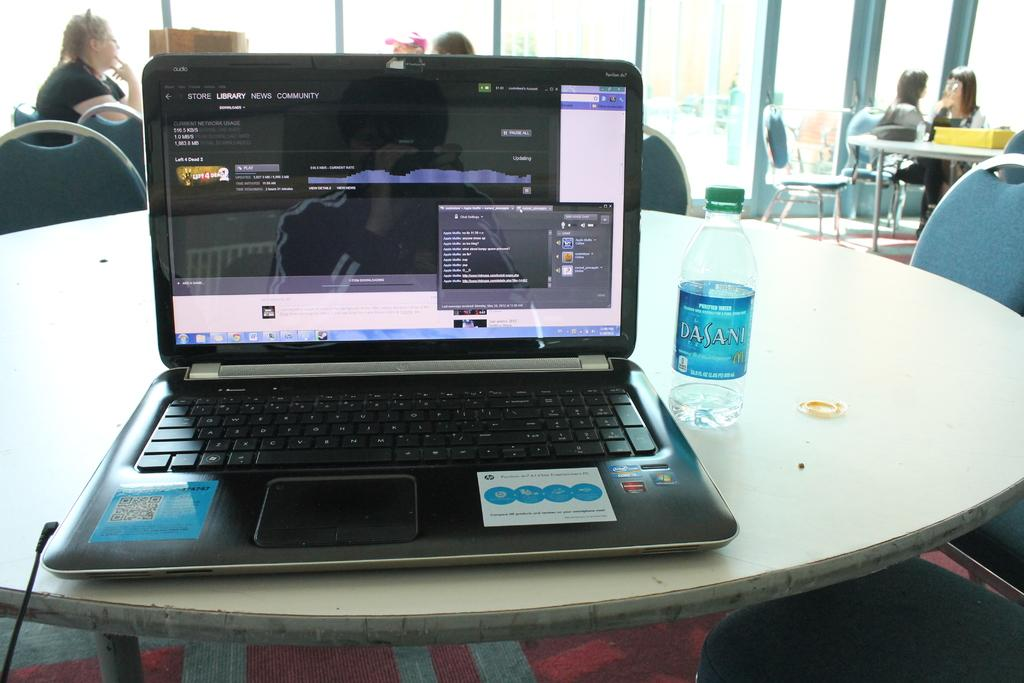<image>
Render a clear and concise summary of the photo. Black HP laptop on top of a table next to a Dasani bottle. 